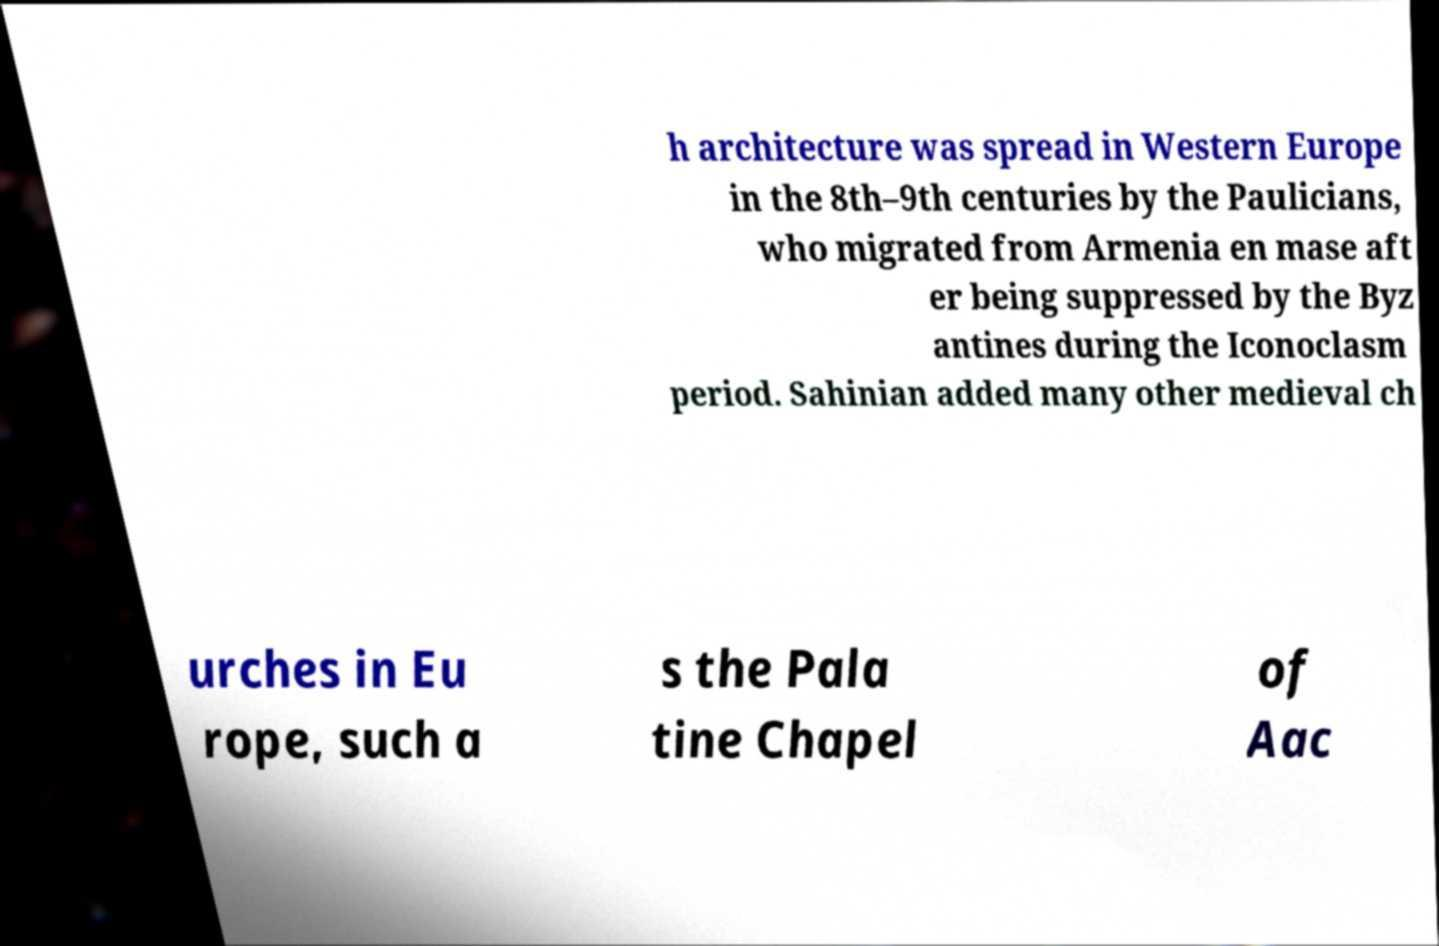Could you extract and type out the text from this image? h architecture was spread in Western Europe in the 8th–9th centuries by the Paulicians, who migrated from Armenia en mase aft er being suppressed by the Byz antines during the Iconoclasm period. Sahinian added many other medieval ch urches in Eu rope, such a s the Pala tine Chapel of Aac 